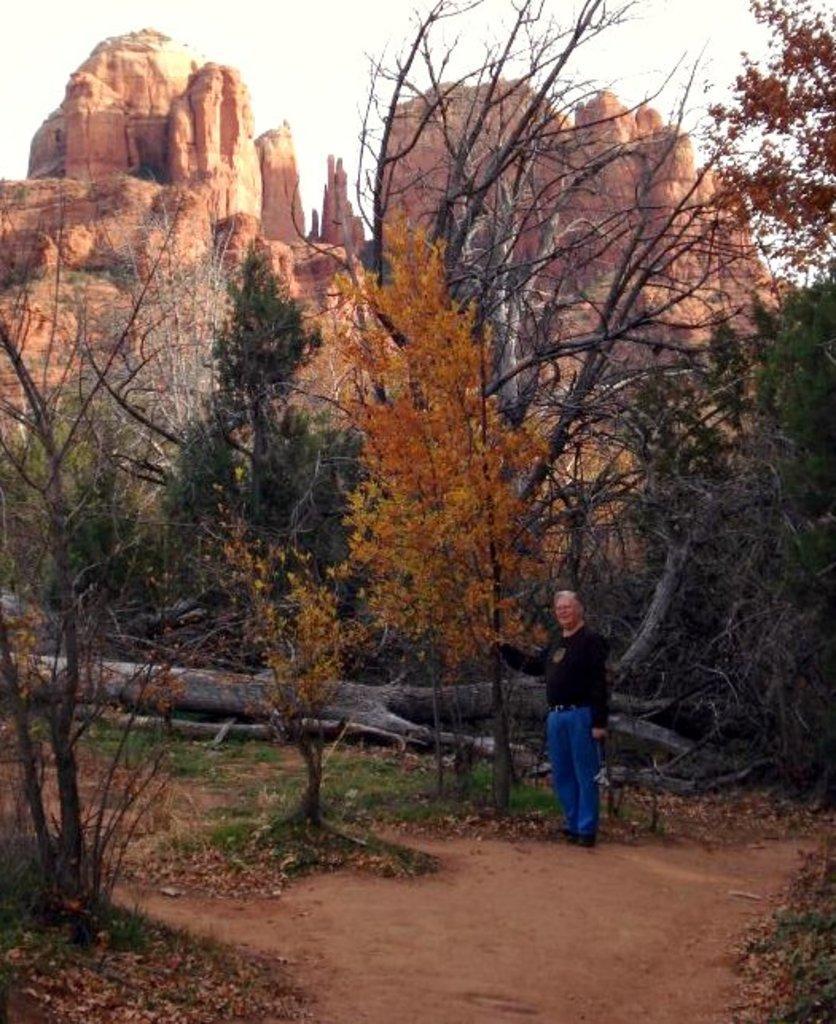Could you give a brief overview of what you see in this image? In this picture we can observe a person wearing black color T shirt. The person is standing beside the yellow color tree. We can observe some dried and green color trees in this picture. In the background there are hills and a sky. 